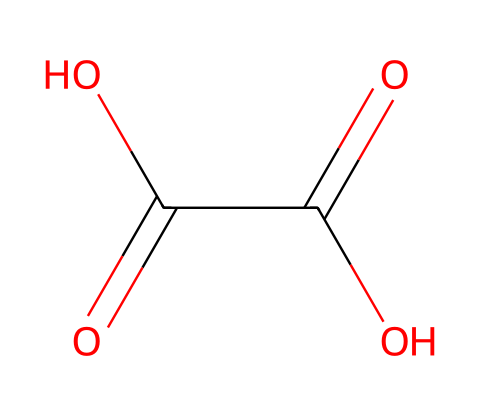What is the molecular formula of oxalic acid? By analyzing the SMILES representation, we can identify the constituent atoms: there are two carbon (C) atoms, four oxygen (O) atoms, and two hydrogen (H) atoms. Therefore, the molecular formula can be deduced as C2H2O4.
Answer: C2H2O4 How many carboxylic acid groups are present in oxalic acid? The structure contains two carboxylic acid moieties, which can be recognized from the C(=O)O pattern in the SMILES. Each C(=O)O represents a carboxylic acid group.
Answer: 2 What type of functional groups are featured in oxalic acid? Upon inspecting the SMILES representation, the notable functional groups present are two carboxylic acid groups, due to the C(=O)O configuration.
Answer: carboxylic acid How many total atoms are in oxalic acid? To ascertain the total number of atoms, we add up the individual atoms: 2 carbon, 2 hydrogen, and 4 oxygen, which totals 8 atoms.
Answer: 8 How many double bonds are present in the structure of oxalic acid? Analyzing the SMILES notation reveals there are two double bonds associated with the C(=O) components, indicating that there are two double bonds in the structure.
Answer: 2 Is oxalic acid classified as aliphatic or aromatic? By analyzing the structure, oxalic acid possesses a linear arrangement of carbon atoms and does not have a conjugated ring structure that characterizes aromatics. Thus, it is classified as aliphatic.
Answer: aliphatic Why does oxalic acid have a relatively low pKa compared to other carboxylic acids? The presence of two carboxylic acid groups in close proximity creates an environment of strong electron-withdrawing effects, which stabilizes the conjugate base upon deprotonation, leading to a lower pKa.
Answer: strong electron-withdrawing effects 